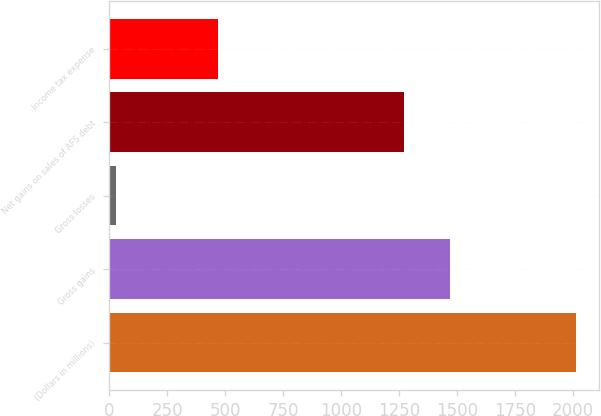Convert chart to OTSL. <chart><loc_0><loc_0><loc_500><loc_500><bar_chart><fcel>(Dollars in millions)<fcel>Gross gains<fcel>Gross losses<fcel>Net gains on sales of AFS debt<fcel>Income tax expense<nl><fcel>2013<fcel>1469.2<fcel>31<fcel>1271<fcel>470<nl></chart> 